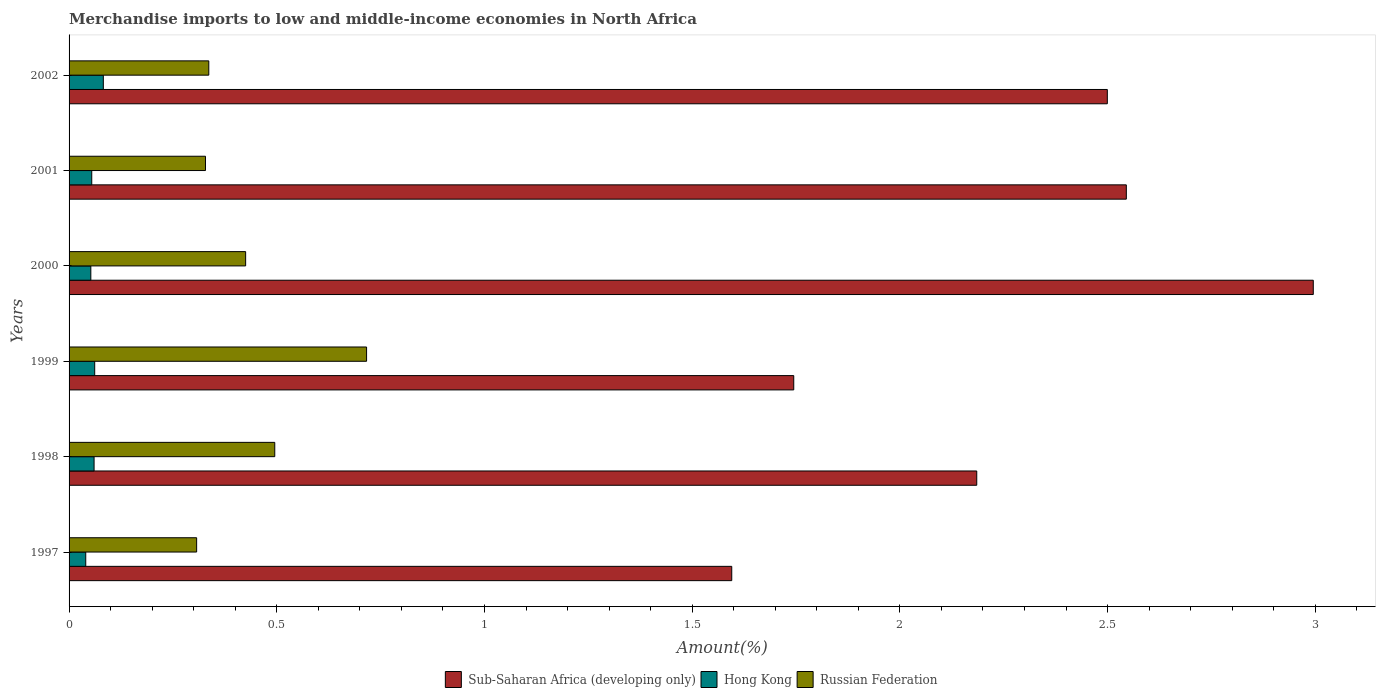How many different coloured bars are there?
Offer a very short reply. 3. How many groups of bars are there?
Offer a terse response. 6. Are the number of bars per tick equal to the number of legend labels?
Provide a succinct answer. Yes. How many bars are there on the 6th tick from the top?
Provide a succinct answer. 3. What is the label of the 6th group of bars from the top?
Give a very brief answer. 1997. What is the percentage of amount earned from merchandise imports in Sub-Saharan Africa (developing only) in 1999?
Provide a short and direct response. 1.74. Across all years, what is the maximum percentage of amount earned from merchandise imports in Hong Kong?
Your response must be concise. 0.08. Across all years, what is the minimum percentage of amount earned from merchandise imports in Hong Kong?
Offer a very short reply. 0.04. In which year was the percentage of amount earned from merchandise imports in Russian Federation minimum?
Your answer should be compact. 1997. What is the total percentage of amount earned from merchandise imports in Hong Kong in the graph?
Keep it short and to the point. 0.35. What is the difference between the percentage of amount earned from merchandise imports in Sub-Saharan Africa (developing only) in 1997 and that in 2000?
Give a very brief answer. -1.4. What is the difference between the percentage of amount earned from merchandise imports in Sub-Saharan Africa (developing only) in 2000 and the percentage of amount earned from merchandise imports in Hong Kong in 1997?
Your answer should be very brief. 2.96. What is the average percentage of amount earned from merchandise imports in Hong Kong per year?
Your answer should be compact. 0.06. In the year 2002, what is the difference between the percentage of amount earned from merchandise imports in Hong Kong and percentage of amount earned from merchandise imports in Sub-Saharan Africa (developing only)?
Keep it short and to the point. -2.42. What is the ratio of the percentage of amount earned from merchandise imports in Hong Kong in 1997 to that in 2002?
Your answer should be very brief. 0.49. Is the difference between the percentage of amount earned from merchandise imports in Hong Kong in 1997 and 2001 greater than the difference between the percentage of amount earned from merchandise imports in Sub-Saharan Africa (developing only) in 1997 and 2001?
Your answer should be very brief. Yes. What is the difference between the highest and the second highest percentage of amount earned from merchandise imports in Hong Kong?
Your answer should be very brief. 0.02. What is the difference between the highest and the lowest percentage of amount earned from merchandise imports in Russian Federation?
Offer a terse response. 0.41. Is the sum of the percentage of amount earned from merchandise imports in Hong Kong in 1997 and 1998 greater than the maximum percentage of amount earned from merchandise imports in Sub-Saharan Africa (developing only) across all years?
Offer a very short reply. No. What does the 2nd bar from the top in 1997 represents?
Ensure brevity in your answer.  Hong Kong. What does the 3rd bar from the bottom in 2000 represents?
Your response must be concise. Russian Federation. Is it the case that in every year, the sum of the percentage of amount earned from merchandise imports in Sub-Saharan Africa (developing only) and percentage of amount earned from merchandise imports in Hong Kong is greater than the percentage of amount earned from merchandise imports in Russian Federation?
Your answer should be very brief. Yes. Are all the bars in the graph horizontal?
Offer a very short reply. Yes. What is the difference between two consecutive major ticks on the X-axis?
Provide a short and direct response. 0.5. Does the graph contain grids?
Your answer should be compact. No. What is the title of the graph?
Give a very brief answer. Merchandise imports to low and middle-income economies in North Africa. Does "Eritrea" appear as one of the legend labels in the graph?
Ensure brevity in your answer.  No. What is the label or title of the X-axis?
Provide a succinct answer. Amount(%). What is the label or title of the Y-axis?
Your response must be concise. Years. What is the Amount(%) of Sub-Saharan Africa (developing only) in 1997?
Provide a succinct answer. 1.6. What is the Amount(%) of Hong Kong in 1997?
Give a very brief answer. 0.04. What is the Amount(%) in Russian Federation in 1997?
Offer a very short reply. 0.31. What is the Amount(%) in Sub-Saharan Africa (developing only) in 1998?
Provide a short and direct response. 2.19. What is the Amount(%) in Hong Kong in 1998?
Provide a short and direct response. 0.06. What is the Amount(%) of Russian Federation in 1998?
Keep it short and to the point. 0.5. What is the Amount(%) of Sub-Saharan Africa (developing only) in 1999?
Your response must be concise. 1.74. What is the Amount(%) of Hong Kong in 1999?
Offer a terse response. 0.06. What is the Amount(%) of Russian Federation in 1999?
Your answer should be compact. 0.72. What is the Amount(%) in Sub-Saharan Africa (developing only) in 2000?
Keep it short and to the point. 3. What is the Amount(%) of Hong Kong in 2000?
Keep it short and to the point. 0.05. What is the Amount(%) of Russian Federation in 2000?
Ensure brevity in your answer.  0.43. What is the Amount(%) of Sub-Saharan Africa (developing only) in 2001?
Your answer should be compact. 2.55. What is the Amount(%) in Hong Kong in 2001?
Ensure brevity in your answer.  0.05. What is the Amount(%) of Russian Federation in 2001?
Your answer should be very brief. 0.33. What is the Amount(%) in Sub-Saharan Africa (developing only) in 2002?
Provide a succinct answer. 2.5. What is the Amount(%) in Hong Kong in 2002?
Provide a succinct answer. 0.08. What is the Amount(%) of Russian Federation in 2002?
Your answer should be very brief. 0.34. Across all years, what is the maximum Amount(%) of Sub-Saharan Africa (developing only)?
Make the answer very short. 3. Across all years, what is the maximum Amount(%) of Hong Kong?
Keep it short and to the point. 0.08. Across all years, what is the maximum Amount(%) in Russian Federation?
Provide a short and direct response. 0.72. Across all years, what is the minimum Amount(%) of Sub-Saharan Africa (developing only)?
Keep it short and to the point. 1.6. Across all years, what is the minimum Amount(%) in Hong Kong?
Make the answer very short. 0.04. Across all years, what is the minimum Amount(%) in Russian Federation?
Provide a short and direct response. 0.31. What is the total Amount(%) in Sub-Saharan Africa (developing only) in the graph?
Offer a terse response. 13.56. What is the total Amount(%) of Hong Kong in the graph?
Make the answer very short. 0.35. What is the total Amount(%) of Russian Federation in the graph?
Provide a succinct answer. 2.61. What is the difference between the Amount(%) of Sub-Saharan Africa (developing only) in 1997 and that in 1998?
Your response must be concise. -0.59. What is the difference between the Amount(%) of Hong Kong in 1997 and that in 1998?
Provide a succinct answer. -0.02. What is the difference between the Amount(%) of Russian Federation in 1997 and that in 1998?
Offer a very short reply. -0.19. What is the difference between the Amount(%) in Sub-Saharan Africa (developing only) in 1997 and that in 1999?
Provide a succinct answer. -0.15. What is the difference between the Amount(%) of Hong Kong in 1997 and that in 1999?
Offer a terse response. -0.02. What is the difference between the Amount(%) of Russian Federation in 1997 and that in 1999?
Your answer should be very brief. -0.41. What is the difference between the Amount(%) of Sub-Saharan Africa (developing only) in 1997 and that in 2000?
Your response must be concise. -1.4. What is the difference between the Amount(%) in Hong Kong in 1997 and that in 2000?
Provide a succinct answer. -0.01. What is the difference between the Amount(%) in Russian Federation in 1997 and that in 2000?
Provide a short and direct response. -0.12. What is the difference between the Amount(%) in Sub-Saharan Africa (developing only) in 1997 and that in 2001?
Your answer should be very brief. -0.95. What is the difference between the Amount(%) of Hong Kong in 1997 and that in 2001?
Offer a very short reply. -0.01. What is the difference between the Amount(%) of Russian Federation in 1997 and that in 2001?
Make the answer very short. -0.02. What is the difference between the Amount(%) of Sub-Saharan Africa (developing only) in 1997 and that in 2002?
Offer a terse response. -0.9. What is the difference between the Amount(%) in Hong Kong in 1997 and that in 2002?
Your response must be concise. -0.04. What is the difference between the Amount(%) of Russian Federation in 1997 and that in 2002?
Make the answer very short. -0.03. What is the difference between the Amount(%) of Sub-Saharan Africa (developing only) in 1998 and that in 1999?
Your response must be concise. 0.44. What is the difference between the Amount(%) in Hong Kong in 1998 and that in 1999?
Make the answer very short. -0. What is the difference between the Amount(%) in Russian Federation in 1998 and that in 1999?
Provide a succinct answer. -0.22. What is the difference between the Amount(%) of Sub-Saharan Africa (developing only) in 1998 and that in 2000?
Offer a very short reply. -0.81. What is the difference between the Amount(%) of Hong Kong in 1998 and that in 2000?
Give a very brief answer. 0.01. What is the difference between the Amount(%) in Russian Federation in 1998 and that in 2000?
Your answer should be compact. 0.07. What is the difference between the Amount(%) of Sub-Saharan Africa (developing only) in 1998 and that in 2001?
Your response must be concise. -0.36. What is the difference between the Amount(%) in Hong Kong in 1998 and that in 2001?
Your answer should be very brief. 0.01. What is the difference between the Amount(%) in Russian Federation in 1998 and that in 2001?
Ensure brevity in your answer.  0.17. What is the difference between the Amount(%) in Sub-Saharan Africa (developing only) in 1998 and that in 2002?
Provide a succinct answer. -0.31. What is the difference between the Amount(%) in Hong Kong in 1998 and that in 2002?
Your answer should be compact. -0.02. What is the difference between the Amount(%) in Russian Federation in 1998 and that in 2002?
Keep it short and to the point. 0.16. What is the difference between the Amount(%) in Sub-Saharan Africa (developing only) in 1999 and that in 2000?
Make the answer very short. -1.25. What is the difference between the Amount(%) in Hong Kong in 1999 and that in 2000?
Keep it short and to the point. 0.01. What is the difference between the Amount(%) of Russian Federation in 1999 and that in 2000?
Offer a very short reply. 0.29. What is the difference between the Amount(%) in Sub-Saharan Africa (developing only) in 1999 and that in 2001?
Your response must be concise. -0.8. What is the difference between the Amount(%) of Hong Kong in 1999 and that in 2001?
Your answer should be compact. 0.01. What is the difference between the Amount(%) of Russian Federation in 1999 and that in 2001?
Give a very brief answer. 0.39. What is the difference between the Amount(%) of Sub-Saharan Africa (developing only) in 1999 and that in 2002?
Provide a succinct answer. -0.75. What is the difference between the Amount(%) of Hong Kong in 1999 and that in 2002?
Provide a short and direct response. -0.02. What is the difference between the Amount(%) of Russian Federation in 1999 and that in 2002?
Your response must be concise. 0.38. What is the difference between the Amount(%) of Sub-Saharan Africa (developing only) in 2000 and that in 2001?
Make the answer very short. 0.45. What is the difference between the Amount(%) of Hong Kong in 2000 and that in 2001?
Give a very brief answer. -0. What is the difference between the Amount(%) of Russian Federation in 2000 and that in 2001?
Your answer should be very brief. 0.1. What is the difference between the Amount(%) in Sub-Saharan Africa (developing only) in 2000 and that in 2002?
Give a very brief answer. 0.5. What is the difference between the Amount(%) of Hong Kong in 2000 and that in 2002?
Make the answer very short. -0.03. What is the difference between the Amount(%) in Russian Federation in 2000 and that in 2002?
Offer a very short reply. 0.09. What is the difference between the Amount(%) of Sub-Saharan Africa (developing only) in 2001 and that in 2002?
Keep it short and to the point. 0.05. What is the difference between the Amount(%) of Hong Kong in 2001 and that in 2002?
Offer a terse response. -0.03. What is the difference between the Amount(%) of Russian Federation in 2001 and that in 2002?
Your response must be concise. -0.01. What is the difference between the Amount(%) of Sub-Saharan Africa (developing only) in 1997 and the Amount(%) of Hong Kong in 1998?
Ensure brevity in your answer.  1.54. What is the difference between the Amount(%) in Sub-Saharan Africa (developing only) in 1997 and the Amount(%) in Russian Federation in 1998?
Provide a succinct answer. 1.1. What is the difference between the Amount(%) of Hong Kong in 1997 and the Amount(%) of Russian Federation in 1998?
Keep it short and to the point. -0.46. What is the difference between the Amount(%) in Sub-Saharan Africa (developing only) in 1997 and the Amount(%) in Hong Kong in 1999?
Offer a terse response. 1.53. What is the difference between the Amount(%) in Sub-Saharan Africa (developing only) in 1997 and the Amount(%) in Russian Federation in 1999?
Your answer should be compact. 0.88. What is the difference between the Amount(%) of Hong Kong in 1997 and the Amount(%) of Russian Federation in 1999?
Your response must be concise. -0.68. What is the difference between the Amount(%) in Sub-Saharan Africa (developing only) in 1997 and the Amount(%) in Hong Kong in 2000?
Your answer should be compact. 1.54. What is the difference between the Amount(%) of Sub-Saharan Africa (developing only) in 1997 and the Amount(%) of Russian Federation in 2000?
Your answer should be compact. 1.17. What is the difference between the Amount(%) of Hong Kong in 1997 and the Amount(%) of Russian Federation in 2000?
Ensure brevity in your answer.  -0.38. What is the difference between the Amount(%) in Sub-Saharan Africa (developing only) in 1997 and the Amount(%) in Hong Kong in 2001?
Keep it short and to the point. 1.54. What is the difference between the Amount(%) in Sub-Saharan Africa (developing only) in 1997 and the Amount(%) in Russian Federation in 2001?
Your answer should be very brief. 1.27. What is the difference between the Amount(%) of Hong Kong in 1997 and the Amount(%) of Russian Federation in 2001?
Your response must be concise. -0.29. What is the difference between the Amount(%) in Sub-Saharan Africa (developing only) in 1997 and the Amount(%) in Hong Kong in 2002?
Your answer should be very brief. 1.51. What is the difference between the Amount(%) in Sub-Saharan Africa (developing only) in 1997 and the Amount(%) in Russian Federation in 2002?
Your response must be concise. 1.26. What is the difference between the Amount(%) of Hong Kong in 1997 and the Amount(%) of Russian Federation in 2002?
Keep it short and to the point. -0.3. What is the difference between the Amount(%) in Sub-Saharan Africa (developing only) in 1998 and the Amount(%) in Hong Kong in 1999?
Provide a short and direct response. 2.12. What is the difference between the Amount(%) in Sub-Saharan Africa (developing only) in 1998 and the Amount(%) in Russian Federation in 1999?
Provide a short and direct response. 1.47. What is the difference between the Amount(%) of Hong Kong in 1998 and the Amount(%) of Russian Federation in 1999?
Provide a succinct answer. -0.66. What is the difference between the Amount(%) in Sub-Saharan Africa (developing only) in 1998 and the Amount(%) in Hong Kong in 2000?
Ensure brevity in your answer.  2.13. What is the difference between the Amount(%) of Sub-Saharan Africa (developing only) in 1998 and the Amount(%) of Russian Federation in 2000?
Keep it short and to the point. 1.76. What is the difference between the Amount(%) of Hong Kong in 1998 and the Amount(%) of Russian Federation in 2000?
Keep it short and to the point. -0.36. What is the difference between the Amount(%) in Sub-Saharan Africa (developing only) in 1998 and the Amount(%) in Hong Kong in 2001?
Provide a succinct answer. 2.13. What is the difference between the Amount(%) of Sub-Saharan Africa (developing only) in 1998 and the Amount(%) of Russian Federation in 2001?
Your answer should be compact. 1.86. What is the difference between the Amount(%) in Hong Kong in 1998 and the Amount(%) in Russian Federation in 2001?
Provide a short and direct response. -0.27. What is the difference between the Amount(%) of Sub-Saharan Africa (developing only) in 1998 and the Amount(%) of Hong Kong in 2002?
Keep it short and to the point. 2.1. What is the difference between the Amount(%) in Sub-Saharan Africa (developing only) in 1998 and the Amount(%) in Russian Federation in 2002?
Your answer should be very brief. 1.85. What is the difference between the Amount(%) in Hong Kong in 1998 and the Amount(%) in Russian Federation in 2002?
Your answer should be compact. -0.28. What is the difference between the Amount(%) of Sub-Saharan Africa (developing only) in 1999 and the Amount(%) of Hong Kong in 2000?
Provide a succinct answer. 1.69. What is the difference between the Amount(%) in Sub-Saharan Africa (developing only) in 1999 and the Amount(%) in Russian Federation in 2000?
Your answer should be compact. 1.32. What is the difference between the Amount(%) in Hong Kong in 1999 and the Amount(%) in Russian Federation in 2000?
Provide a short and direct response. -0.36. What is the difference between the Amount(%) in Sub-Saharan Africa (developing only) in 1999 and the Amount(%) in Hong Kong in 2001?
Ensure brevity in your answer.  1.69. What is the difference between the Amount(%) of Sub-Saharan Africa (developing only) in 1999 and the Amount(%) of Russian Federation in 2001?
Your response must be concise. 1.42. What is the difference between the Amount(%) of Hong Kong in 1999 and the Amount(%) of Russian Federation in 2001?
Ensure brevity in your answer.  -0.27. What is the difference between the Amount(%) of Sub-Saharan Africa (developing only) in 1999 and the Amount(%) of Hong Kong in 2002?
Ensure brevity in your answer.  1.66. What is the difference between the Amount(%) in Sub-Saharan Africa (developing only) in 1999 and the Amount(%) in Russian Federation in 2002?
Your answer should be very brief. 1.41. What is the difference between the Amount(%) of Hong Kong in 1999 and the Amount(%) of Russian Federation in 2002?
Your response must be concise. -0.27. What is the difference between the Amount(%) of Sub-Saharan Africa (developing only) in 2000 and the Amount(%) of Hong Kong in 2001?
Make the answer very short. 2.94. What is the difference between the Amount(%) in Sub-Saharan Africa (developing only) in 2000 and the Amount(%) in Russian Federation in 2001?
Your answer should be compact. 2.67. What is the difference between the Amount(%) of Hong Kong in 2000 and the Amount(%) of Russian Federation in 2001?
Provide a short and direct response. -0.28. What is the difference between the Amount(%) of Sub-Saharan Africa (developing only) in 2000 and the Amount(%) of Hong Kong in 2002?
Ensure brevity in your answer.  2.91. What is the difference between the Amount(%) of Sub-Saharan Africa (developing only) in 2000 and the Amount(%) of Russian Federation in 2002?
Provide a succinct answer. 2.66. What is the difference between the Amount(%) of Hong Kong in 2000 and the Amount(%) of Russian Federation in 2002?
Provide a succinct answer. -0.28. What is the difference between the Amount(%) of Sub-Saharan Africa (developing only) in 2001 and the Amount(%) of Hong Kong in 2002?
Ensure brevity in your answer.  2.46. What is the difference between the Amount(%) in Sub-Saharan Africa (developing only) in 2001 and the Amount(%) in Russian Federation in 2002?
Provide a succinct answer. 2.21. What is the difference between the Amount(%) in Hong Kong in 2001 and the Amount(%) in Russian Federation in 2002?
Your answer should be compact. -0.28. What is the average Amount(%) in Sub-Saharan Africa (developing only) per year?
Make the answer very short. 2.26. What is the average Amount(%) of Hong Kong per year?
Offer a very short reply. 0.06. What is the average Amount(%) in Russian Federation per year?
Provide a short and direct response. 0.43. In the year 1997, what is the difference between the Amount(%) of Sub-Saharan Africa (developing only) and Amount(%) of Hong Kong?
Your response must be concise. 1.56. In the year 1997, what is the difference between the Amount(%) in Sub-Saharan Africa (developing only) and Amount(%) in Russian Federation?
Provide a succinct answer. 1.29. In the year 1997, what is the difference between the Amount(%) of Hong Kong and Amount(%) of Russian Federation?
Provide a succinct answer. -0.27. In the year 1998, what is the difference between the Amount(%) in Sub-Saharan Africa (developing only) and Amount(%) in Hong Kong?
Ensure brevity in your answer.  2.12. In the year 1998, what is the difference between the Amount(%) of Sub-Saharan Africa (developing only) and Amount(%) of Russian Federation?
Give a very brief answer. 1.69. In the year 1998, what is the difference between the Amount(%) of Hong Kong and Amount(%) of Russian Federation?
Make the answer very short. -0.43. In the year 1999, what is the difference between the Amount(%) of Sub-Saharan Africa (developing only) and Amount(%) of Hong Kong?
Ensure brevity in your answer.  1.68. In the year 1999, what is the difference between the Amount(%) in Sub-Saharan Africa (developing only) and Amount(%) in Russian Federation?
Your answer should be compact. 1.03. In the year 1999, what is the difference between the Amount(%) in Hong Kong and Amount(%) in Russian Federation?
Ensure brevity in your answer.  -0.65. In the year 2000, what is the difference between the Amount(%) of Sub-Saharan Africa (developing only) and Amount(%) of Hong Kong?
Offer a terse response. 2.94. In the year 2000, what is the difference between the Amount(%) of Sub-Saharan Africa (developing only) and Amount(%) of Russian Federation?
Provide a short and direct response. 2.57. In the year 2000, what is the difference between the Amount(%) in Hong Kong and Amount(%) in Russian Federation?
Offer a terse response. -0.37. In the year 2001, what is the difference between the Amount(%) of Sub-Saharan Africa (developing only) and Amount(%) of Hong Kong?
Ensure brevity in your answer.  2.49. In the year 2001, what is the difference between the Amount(%) of Sub-Saharan Africa (developing only) and Amount(%) of Russian Federation?
Give a very brief answer. 2.22. In the year 2001, what is the difference between the Amount(%) in Hong Kong and Amount(%) in Russian Federation?
Your answer should be very brief. -0.27. In the year 2002, what is the difference between the Amount(%) in Sub-Saharan Africa (developing only) and Amount(%) in Hong Kong?
Your answer should be very brief. 2.42. In the year 2002, what is the difference between the Amount(%) in Sub-Saharan Africa (developing only) and Amount(%) in Russian Federation?
Your answer should be very brief. 2.16. In the year 2002, what is the difference between the Amount(%) of Hong Kong and Amount(%) of Russian Federation?
Your response must be concise. -0.25. What is the ratio of the Amount(%) of Sub-Saharan Africa (developing only) in 1997 to that in 1998?
Your response must be concise. 0.73. What is the ratio of the Amount(%) of Hong Kong in 1997 to that in 1998?
Your response must be concise. 0.67. What is the ratio of the Amount(%) of Russian Federation in 1997 to that in 1998?
Your response must be concise. 0.62. What is the ratio of the Amount(%) of Sub-Saharan Africa (developing only) in 1997 to that in 1999?
Make the answer very short. 0.91. What is the ratio of the Amount(%) in Hong Kong in 1997 to that in 1999?
Give a very brief answer. 0.65. What is the ratio of the Amount(%) of Russian Federation in 1997 to that in 1999?
Offer a very short reply. 0.43. What is the ratio of the Amount(%) of Sub-Saharan Africa (developing only) in 1997 to that in 2000?
Ensure brevity in your answer.  0.53. What is the ratio of the Amount(%) of Hong Kong in 1997 to that in 2000?
Give a very brief answer. 0.77. What is the ratio of the Amount(%) of Russian Federation in 1997 to that in 2000?
Give a very brief answer. 0.72. What is the ratio of the Amount(%) in Sub-Saharan Africa (developing only) in 1997 to that in 2001?
Offer a terse response. 0.63. What is the ratio of the Amount(%) in Hong Kong in 1997 to that in 2001?
Your response must be concise. 0.74. What is the ratio of the Amount(%) of Russian Federation in 1997 to that in 2001?
Give a very brief answer. 0.94. What is the ratio of the Amount(%) in Sub-Saharan Africa (developing only) in 1997 to that in 2002?
Make the answer very short. 0.64. What is the ratio of the Amount(%) in Hong Kong in 1997 to that in 2002?
Provide a short and direct response. 0.49. What is the ratio of the Amount(%) of Sub-Saharan Africa (developing only) in 1998 to that in 1999?
Offer a very short reply. 1.25. What is the ratio of the Amount(%) in Hong Kong in 1998 to that in 1999?
Make the answer very short. 0.98. What is the ratio of the Amount(%) in Russian Federation in 1998 to that in 1999?
Offer a very short reply. 0.69. What is the ratio of the Amount(%) of Sub-Saharan Africa (developing only) in 1998 to that in 2000?
Provide a short and direct response. 0.73. What is the ratio of the Amount(%) in Hong Kong in 1998 to that in 2000?
Your answer should be very brief. 1.15. What is the ratio of the Amount(%) of Russian Federation in 1998 to that in 2000?
Provide a succinct answer. 1.17. What is the ratio of the Amount(%) in Sub-Saharan Africa (developing only) in 1998 to that in 2001?
Ensure brevity in your answer.  0.86. What is the ratio of the Amount(%) of Hong Kong in 1998 to that in 2001?
Give a very brief answer. 1.1. What is the ratio of the Amount(%) of Russian Federation in 1998 to that in 2001?
Provide a succinct answer. 1.51. What is the ratio of the Amount(%) of Sub-Saharan Africa (developing only) in 1998 to that in 2002?
Your answer should be compact. 0.87. What is the ratio of the Amount(%) of Hong Kong in 1998 to that in 2002?
Offer a terse response. 0.73. What is the ratio of the Amount(%) of Russian Federation in 1998 to that in 2002?
Keep it short and to the point. 1.47. What is the ratio of the Amount(%) of Sub-Saharan Africa (developing only) in 1999 to that in 2000?
Your answer should be very brief. 0.58. What is the ratio of the Amount(%) of Hong Kong in 1999 to that in 2000?
Provide a succinct answer. 1.18. What is the ratio of the Amount(%) of Russian Federation in 1999 to that in 2000?
Offer a very short reply. 1.68. What is the ratio of the Amount(%) in Sub-Saharan Africa (developing only) in 1999 to that in 2001?
Give a very brief answer. 0.69. What is the ratio of the Amount(%) of Hong Kong in 1999 to that in 2001?
Your answer should be compact. 1.13. What is the ratio of the Amount(%) in Russian Federation in 1999 to that in 2001?
Your answer should be compact. 2.18. What is the ratio of the Amount(%) of Sub-Saharan Africa (developing only) in 1999 to that in 2002?
Offer a terse response. 0.7. What is the ratio of the Amount(%) of Hong Kong in 1999 to that in 2002?
Keep it short and to the point. 0.75. What is the ratio of the Amount(%) of Russian Federation in 1999 to that in 2002?
Make the answer very short. 2.13. What is the ratio of the Amount(%) of Sub-Saharan Africa (developing only) in 2000 to that in 2001?
Your answer should be very brief. 1.18. What is the ratio of the Amount(%) of Hong Kong in 2000 to that in 2001?
Provide a succinct answer. 0.96. What is the ratio of the Amount(%) of Russian Federation in 2000 to that in 2001?
Offer a very short reply. 1.29. What is the ratio of the Amount(%) of Sub-Saharan Africa (developing only) in 2000 to that in 2002?
Offer a terse response. 1.2. What is the ratio of the Amount(%) of Hong Kong in 2000 to that in 2002?
Your answer should be compact. 0.64. What is the ratio of the Amount(%) in Russian Federation in 2000 to that in 2002?
Ensure brevity in your answer.  1.26. What is the ratio of the Amount(%) in Sub-Saharan Africa (developing only) in 2001 to that in 2002?
Provide a short and direct response. 1.02. What is the ratio of the Amount(%) in Hong Kong in 2001 to that in 2002?
Your response must be concise. 0.66. What is the ratio of the Amount(%) in Russian Federation in 2001 to that in 2002?
Offer a terse response. 0.98. What is the difference between the highest and the second highest Amount(%) of Sub-Saharan Africa (developing only)?
Your response must be concise. 0.45. What is the difference between the highest and the second highest Amount(%) of Hong Kong?
Provide a short and direct response. 0.02. What is the difference between the highest and the second highest Amount(%) in Russian Federation?
Offer a very short reply. 0.22. What is the difference between the highest and the lowest Amount(%) of Sub-Saharan Africa (developing only)?
Your answer should be compact. 1.4. What is the difference between the highest and the lowest Amount(%) in Hong Kong?
Make the answer very short. 0.04. What is the difference between the highest and the lowest Amount(%) in Russian Federation?
Provide a succinct answer. 0.41. 